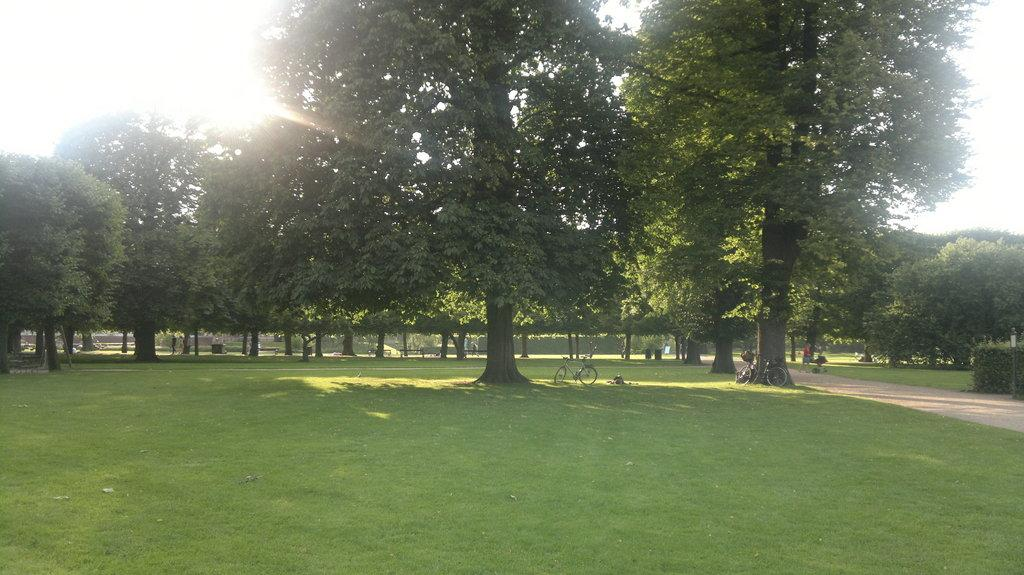What type of terrain is visible in the foreground of the image? There is a grassland in the foreground of the image. What can be seen in the background of the image? There are trees and bicycles on the grass in the background. What is the man in the image doing? The man is walking on a path in the background. What celestial body is visible in the image? The sun is visible in the image. What part of the natural environment is visible in the image? The sky is visible in the image. What time of day is it in the image, given that the man is driving a car? There is no car present in the image, and the man is walking on a path, not driving. 